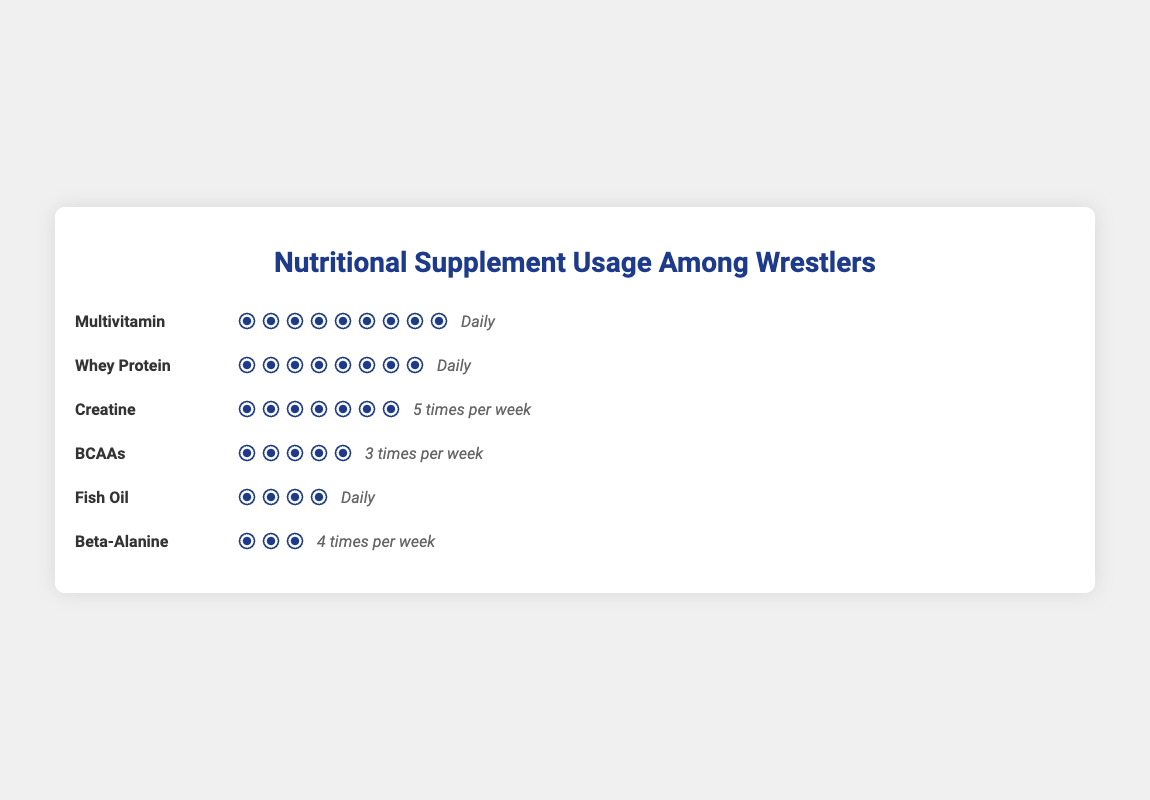Which nutritional supplement is used by the most wrestlers? Look at each supplement's usage count and compare them. Multivitamin has 90 users.
Answer: Multivitamin How frequently do wrestlers use BCAAs? Next to the BCAAs icons, the frequency "3 times per week" is mentioned.
Answer: 3 times per week Which supplements are used daily by wrestlers? Locate "Daily" frequency labels and see which supplements are associated: Multivitamin, Whey Protein, and Fish Oil.
Answer: Multivitamin, Whey Protein, Fish Oil How many more wrestlers use Creatine compared to Beta-Alanine? Creatine has 65 users and Beta-Alanine has 30 users. The difference is 65 - 30 = 35.
Answer: 35 Which supplement has the fewest users, and how many are they? Beta-Alanine has the fewest users. It is used by 30 wrestlers.
Answer: Beta-Alanine, 30 Are there more daily users of Multivitamin or Whey Protein? Compare the usage of Multivitamin (90) and Whey Protein (80). Multivitamin has more users.
Answer: Multivitamin What is the total number of wrestlers using Fish Oil and BCAAs? Sum up the users of Fish Oil (40) and BCAAs (50). The total is 40 + 50 = 90.
Answer: 90 How many times per week do wrestlers take Beta-Alanine? Next to the Beta-Alanine icons, the frequency "4 times per week" is mentioned.
Answer: 4 times per week Which supplement is used by 50 wrestlers and how often? Identify the supplement with 50 users, which is BCAAs, used 3 times per week.
Answer: BCAAs, 3 times per week Which supplement is used more frequently, Creatine or Beta-Alanine? Creatine is used "5 times per week" and Beta-Alanine "4 times per week". Creatine is used more frequently.
Answer: Creatine 